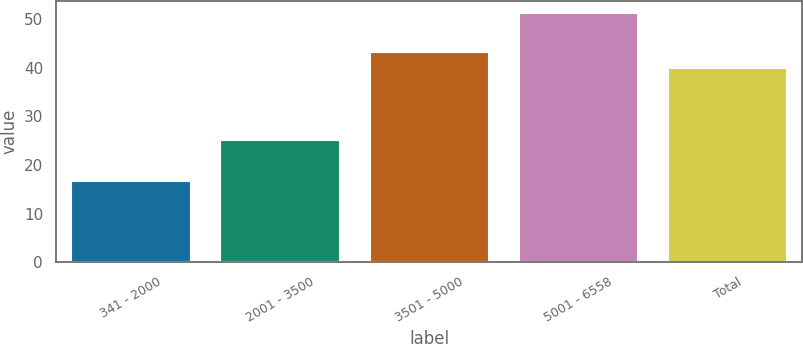Convert chart. <chart><loc_0><loc_0><loc_500><loc_500><bar_chart><fcel>341 - 2000<fcel>2001 - 3500<fcel>3501 - 5000<fcel>5001 - 6558<fcel>Total<nl><fcel>16.63<fcel>25.23<fcel>43.34<fcel>51.27<fcel>39.88<nl></chart> 